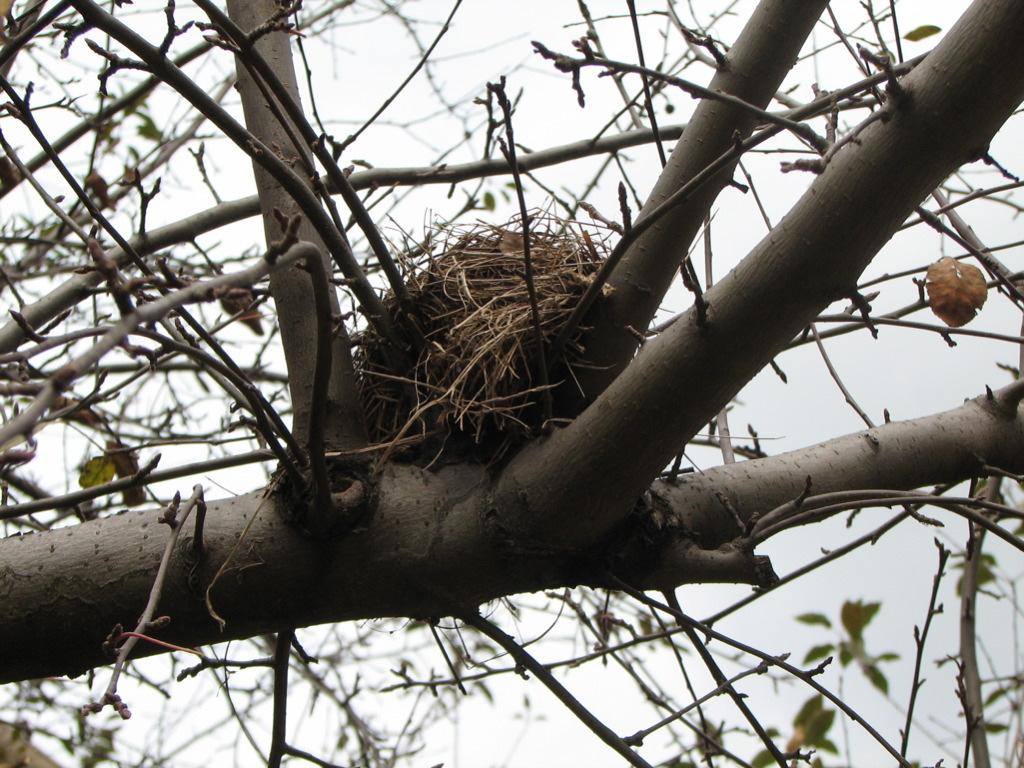What is located on the tree in the image? There is a nest on a tree in the image. What can be seen in the background of the image? The sky is visible in the background of the image. What type of cheese can be seen hanging from the tree in the image? There is no cheese present in the image; it features a nest on a tree. Can you describe the grass in the image? There is no grass visible in the image; it only shows a nest on a tree and the sky in the background. 